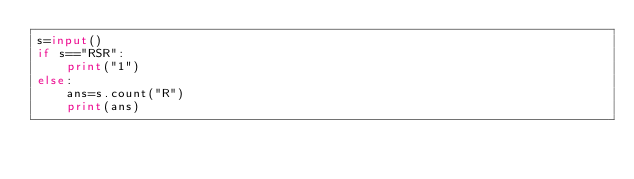Convert code to text. <code><loc_0><loc_0><loc_500><loc_500><_Python_>s=input()
if s=="RSR":
    print("1")
else:
    ans=s.count("R")
    print(ans)
</code> 